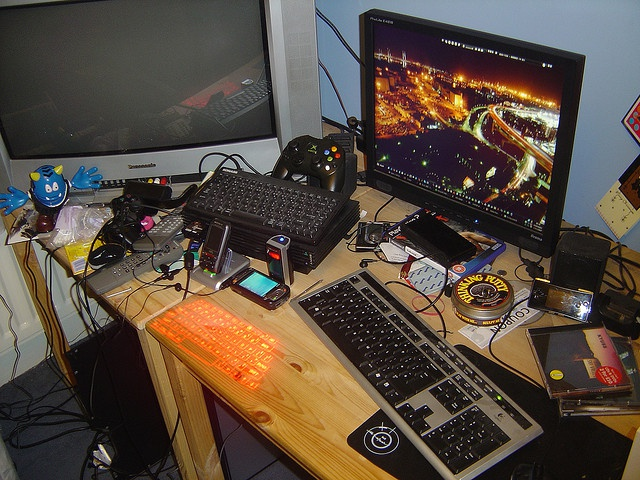Describe the objects in this image and their specific colors. I can see tv in gray, black, and darkgray tones, tv in gray, black, maroon, and brown tones, keyboard in gray and black tones, keyboard in gray, black, and darkgray tones, and remote in gray and black tones in this image. 